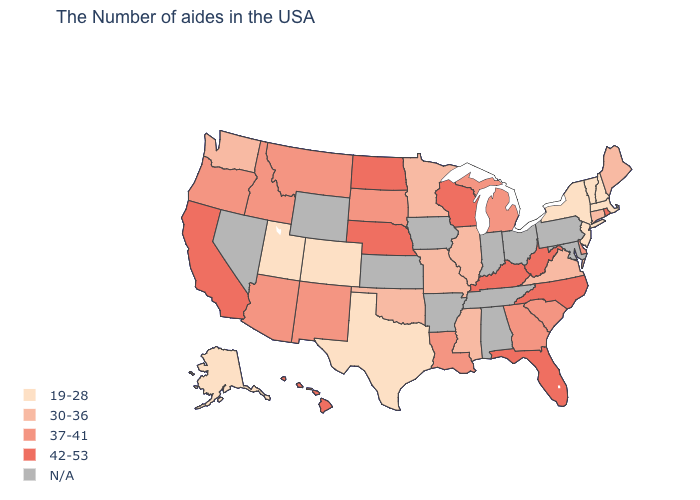Which states have the highest value in the USA?
Give a very brief answer. Rhode Island, North Carolina, West Virginia, Florida, Kentucky, Wisconsin, Nebraska, North Dakota, California, Hawaii. What is the highest value in the USA?
Quick response, please. 42-53. How many symbols are there in the legend?
Be succinct. 5. Which states have the lowest value in the USA?
Short answer required. Massachusetts, New Hampshire, Vermont, New York, New Jersey, Texas, Colorado, Utah, Alaska. Which states have the lowest value in the USA?
Concise answer only. Massachusetts, New Hampshire, Vermont, New York, New Jersey, Texas, Colorado, Utah, Alaska. Is the legend a continuous bar?
Short answer required. No. Does the first symbol in the legend represent the smallest category?
Write a very short answer. Yes. Does New Hampshire have the lowest value in the Northeast?
Answer briefly. Yes. What is the value of Michigan?
Quick response, please. 37-41. What is the value of Wisconsin?
Be succinct. 42-53. Does Kentucky have the highest value in the USA?
Give a very brief answer. Yes. Does Kentucky have the highest value in the South?
Keep it brief. Yes. What is the lowest value in the USA?
Write a very short answer. 19-28. Name the states that have a value in the range 30-36?
Answer briefly. Maine, Connecticut, Virginia, Illinois, Mississippi, Missouri, Minnesota, Oklahoma, Washington. 